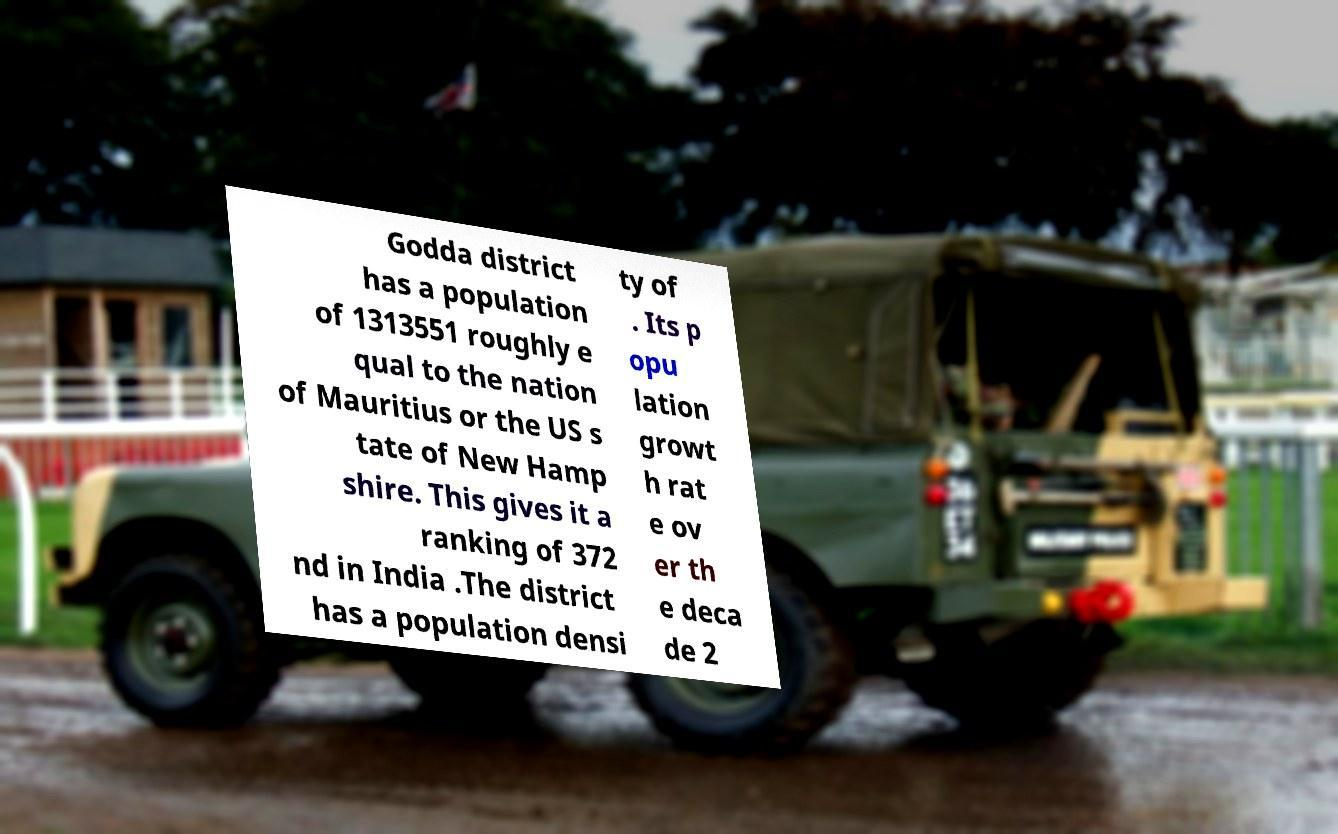Can you read and provide the text displayed in the image?This photo seems to have some interesting text. Can you extract and type it out for me? Godda district has a population of 1313551 roughly e qual to the nation of Mauritius or the US s tate of New Hamp shire. This gives it a ranking of 372 nd in India .The district has a population densi ty of . Its p opu lation growt h rat e ov er th e deca de 2 